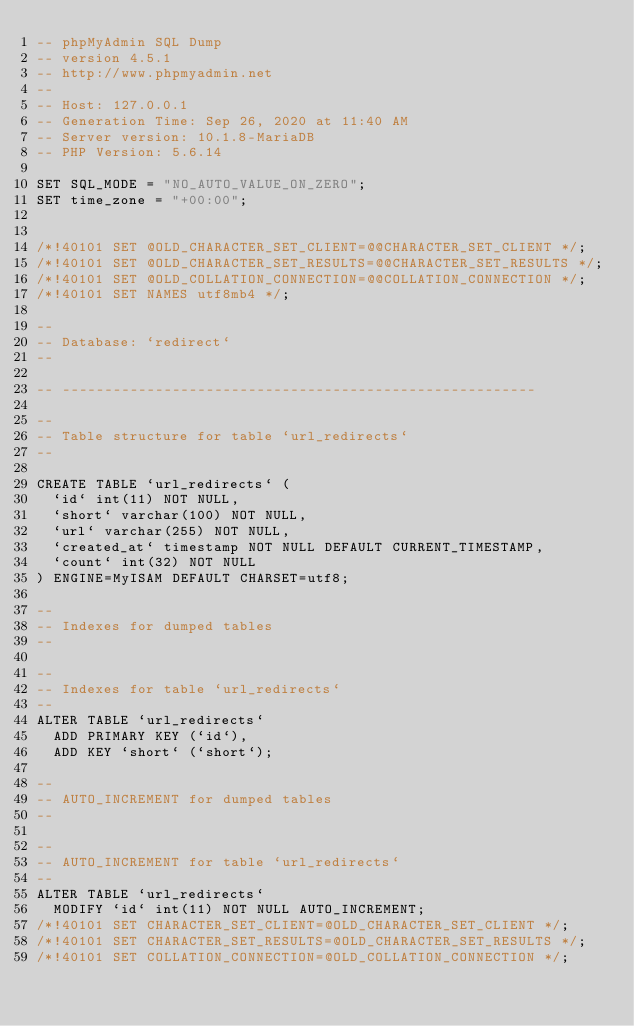<code> <loc_0><loc_0><loc_500><loc_500><_SQL_>-- phpMyAdmin SQL Dump
-- version 4.5.1
-- http://www.phpmyadmin.net
--
-- Host: 127.0.0.1
-- Generation Time: Sep 26, 2020 at 11:40 AM
-- Server version: 10.1.8-MariaDB
-- PHP Version: 5.6.14

SET SQL_MODE = "NO_AUTO_VALUE_ON_ZERO";
SET time_zone = "+00:00";


/*!40101 SET @OLD_CHARACTER_SET_CLIENT=@@CHARACTER_SET_CLIENT */;
/*!40101 SET @OLD_CHARACTER_SET_RESULTS=@@CHARACTER_SET_RESULTS */;
/*!40101 SET @OLD_COLLATION_CONNECTION=@@COLLATION_CONNECTION */;
/*!40101 SET NAMES utf8mb4 */;

--
-- Database: `redirect`
--

-- --------------------------------------------------------

--
-- Table structure for table `url_redirects`
--

CREATE TABLE `url_redirects` (
  `id` int(11) NOT NULL,
  `short` varchar(100) NOT NULL,
  `url` varchar(255) NOT NULL,
  `created_at` timestamp NOT NULL DEFAULT CURRENT_TIMESTAMP,
  `count` int(32) NOT NULL
) ENGINE=MyISAM DEFAULT CHARSET=utf8;

--
-- Indexes for dumped tables
--

--
-- Indexes for table `url_redirects`
--
ALTER TABLE `url_redirects`
  ADD PRIMARY KEY (`id`),
  ADD KEY `short` (`short`);

--
-- AUTO_INCREMENT for dumped tables
--

--
-- AUTO_INCREMENT for table `url_redirects`
--
ALTER TABLE `url_redirects`
  MODIFY `id` int(11) NOT NULL AUTO_INCREMENT;
/*!40101 SET CHARACTER_SET_CLIENT=@OLD_CHARACTER_SET_CLIENT */;
/*!40101 SET CHARACTER_SET_RESULTS=@OLD_CHARACTER_SET_RESULTS */;
/*!40101 SET COLLATION_CONNECTION=@OLD_COLLATION_CONNECTION */;
</code> 